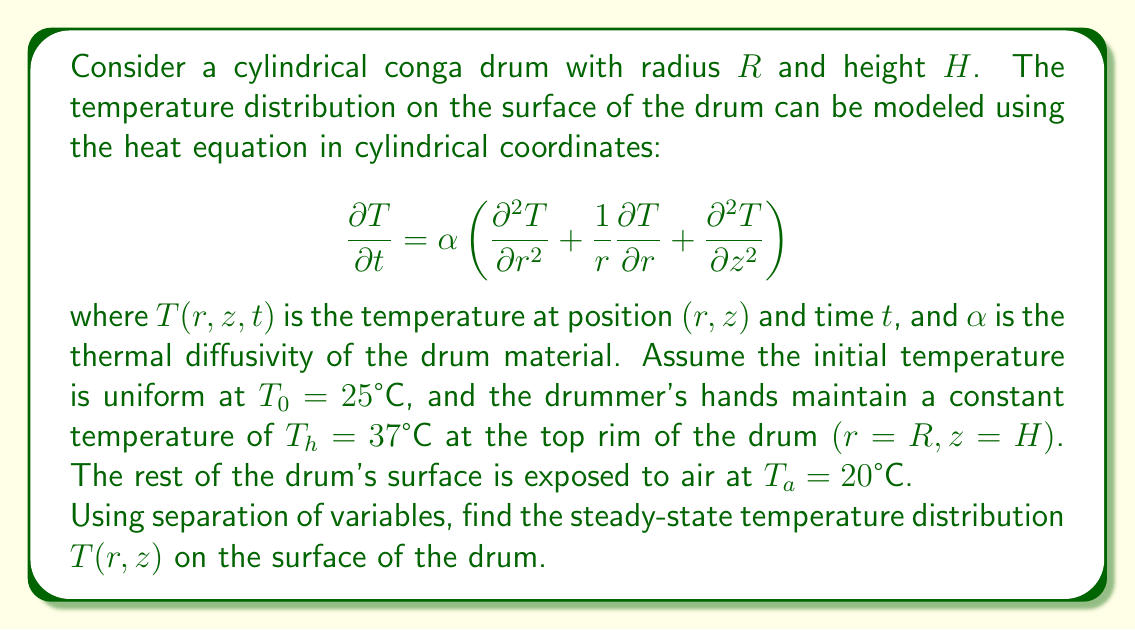Could you help me with this problem? To solve this problem, we'll follow these steps:

1) For the steady-state solution, $\frac{\partial T}{\partial t} = 0$, so our equation becomes:

   $$\frac{\partial^2 T}{\partial r^2} + \frac{1}{r}\frac{\partial T}{\partial r} + \frac{\partial^2 T}{\partial z^2} = 0$$

2) We can use separation of variables, assuming $T(r,z) = R(r)Z(z)$:

   $$\frac{1}{R}\left(\frac{d^2R}{dr^2} + \frac{1}{r}\frac{dR}{dr}\right) = -\frac{1}{Z}\frac{d^2Z}{dz^2} = -\lambda^2$$

3) This gives us two equations:
   
   $$\frac{d^2R}{dr^2} + \frac{1}{r}\frac{dR}{dr} + \lambda^2R = 0$$
   $$\frac{d^2Z}{dz^2} - \lambda^2Z = 0$$

4) The solution for $R(r)$ is a Bessel function of the first kind: $R(r) = J_0(\lambda r)$
   The solution for $Z(z)$ is: $Z(z) = A\sinh(\lambda z) + B\cosh(\lambda z)$

5) Applying the boundary conditions:
   - At $r = 0$, $T$ must be finite, which is satisfied by $J_0(\lambda r)$
   - At $r = R$, $T = T_a$, so $J_0(\lambda R) = 0$. This gives us the eigenvalues $\lambda_n = \frac{\alpha_n}{R}$, where $\alpha_n$ are the zeros of $J_0$
   - At $z = 0$, $T = T_a$, so $B = T_a$
   - At $z = H$, $T = T_h$ at $r = R$, but $T = T_a$ elsewhere

6) The general solution is:

   $$T(r,z) = T_a + \sum_{n=1}^{\infty} C_n J_0(\lambda_n r) \sinh(\lambda_n z)$$

7) To find $C_n$, we use the boundary condition at $z = H$:

   $$T_h - T_a = \sum_{n=1}^{\infty} C_n J_0(\lambda_n R) \sinh(\lambda_n H)$$

   Multiplying both sides by $rJ_0(\lambda_m r)$ and integrating from 0 to $R$:

   $$C_n = \frac{2(T_h - T_a)}{R^2 J_1(\lambda_n R)^2 \sinh(\lambda_n H)}$$

8) Therefore, the final steady-state solution is:

   $$T(r,z) = T_a + \sum_{n=1}^{\infty} \frac{2(T_h - T_a)}{R^2 J_1(\lambda_n R)^2 \sinh(\lambda_n H)} J_0(\lambda_n r) \sinh(\lambda_n z)$$
Answer: The steady-state temperature distribution on the surface of the drum is given by:

$$T(r,z) = T_a + \sum_{n=1}^{\infty} \frac{2(T_h - T_a)}{R^2 J_1(\lambda_n R)^2 \sinh(\lambda_n H)} J_0(\lambda_n r) \sinh(\lambda_n z)$$

where $\lambda_n = \frac{\alpha_n}{R}$, and $\alpha_n$ are the zeros of the Bessel function $J_0$. 